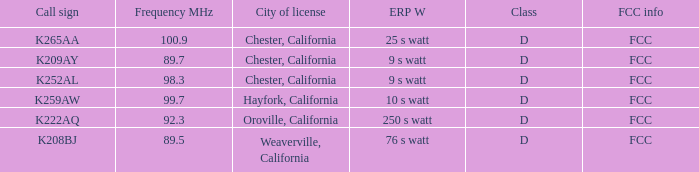Identify the call sign having a frequency of 8 K208BJ. 